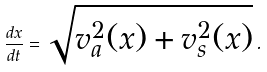Convert formula to latex. <formula><loc_0><loc_0><loc_500><loc_500>\frac { d x } { d t } = \sqrt { v ^ { 2 } _ { a } ( x ) + v ^ { 2 } _ { s } ( x ) } \, .</formula> 